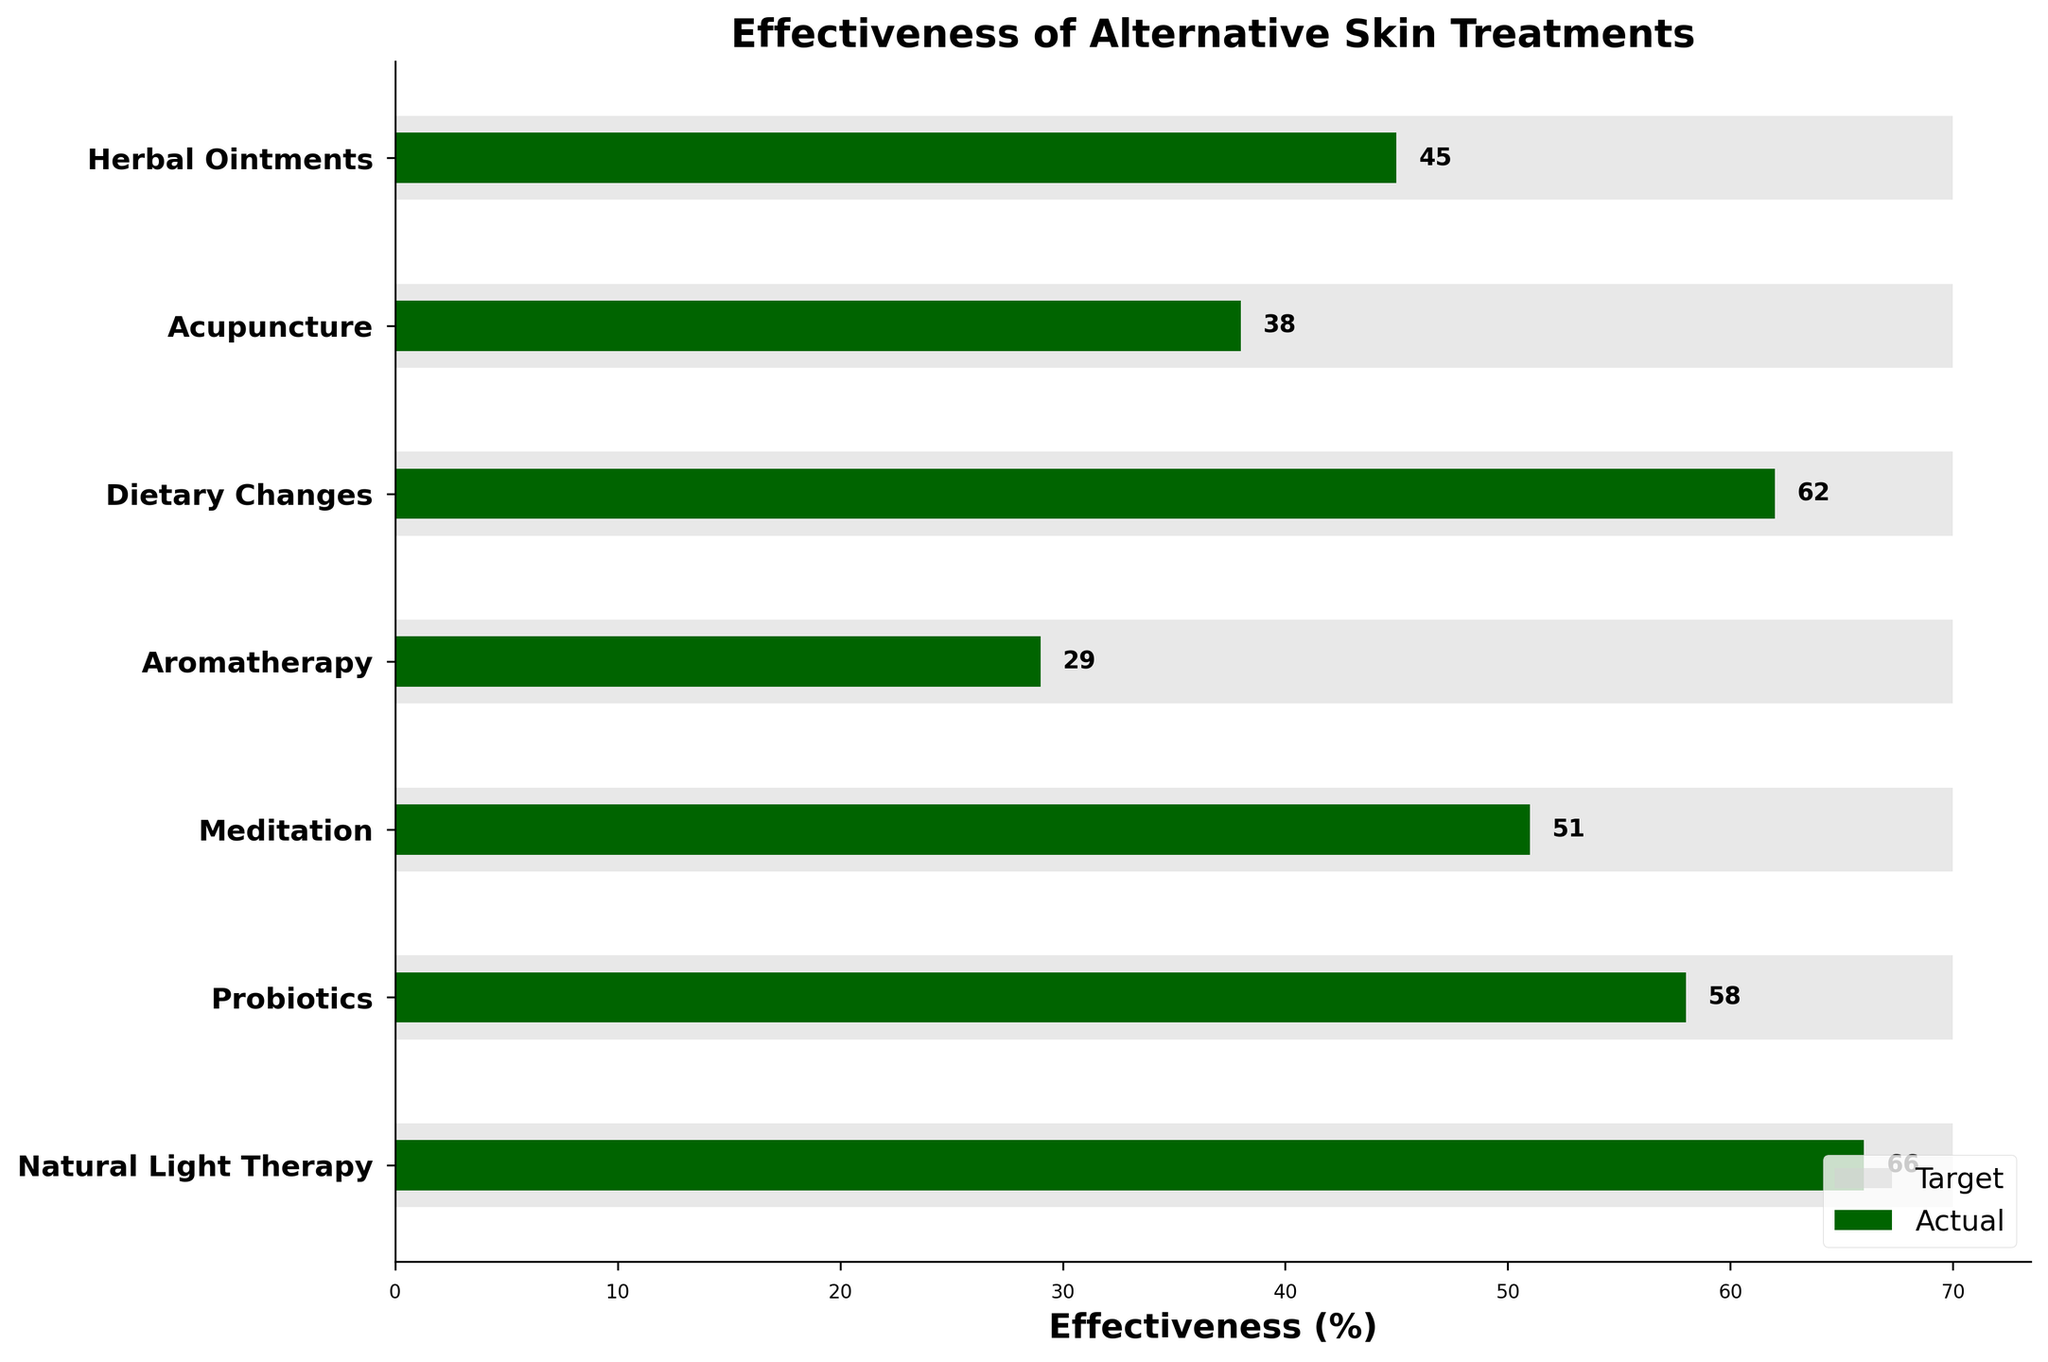What is the title of the chart? The title is usually found at the top center of the chart and it summarizes what the chart is about.
Answer: Effectiveness of Alternative Skin Treatments What are the units on the x-axis? Units on the x-axis indicate the measurement scale; here it's labeled with percentages showing effectiveness.
Answer: Effectiveness (%) How many treatments are shown in the chart? Count the number of unique treatments listed on the y-axis.
Answer: 7 Which treatment has the highest actual effectiveness? Find the bar that extends the farthest to the right; this represents the highest effectiveness.
Answer: Natural Light Therapy Is any treatment meeting the target effectiveness of 70%? Compare the actual values of all treatments to the target line to see if any bar reaches or surpasses the target value.
Answer: No Which treatment has the smallest difference between actual effectiveness and target? Calculate the difference between actual and target for each treatment, identify the smallest difference.
Answer: Natural Light Therapy What is the difference in effectiveness between probiotics and meditation? Subtract the actual effectiveness of meditation from probiotics (58% - 51%).
Answer: 7% Which treatment shows the lowest actual effectiveness? Identify the bar that is shortest; this indicates the lowest effectiveness.
Answer: Aromatherapy Among Herbal Ointments, Acupuncture, and Dietary Changes, which treatment is closest to the target? Compare their actual values with the target, find which one has the smallest gap.
Answer: Dietary Changes What is the average actual effectiveness of all treatments? Sum the actual effectiveness values and divide by the number of treatments: (45 + 38 + 62 + 29 + 51 + 58 + 66) / 7 = 49.857.
Answer: 49.857% 